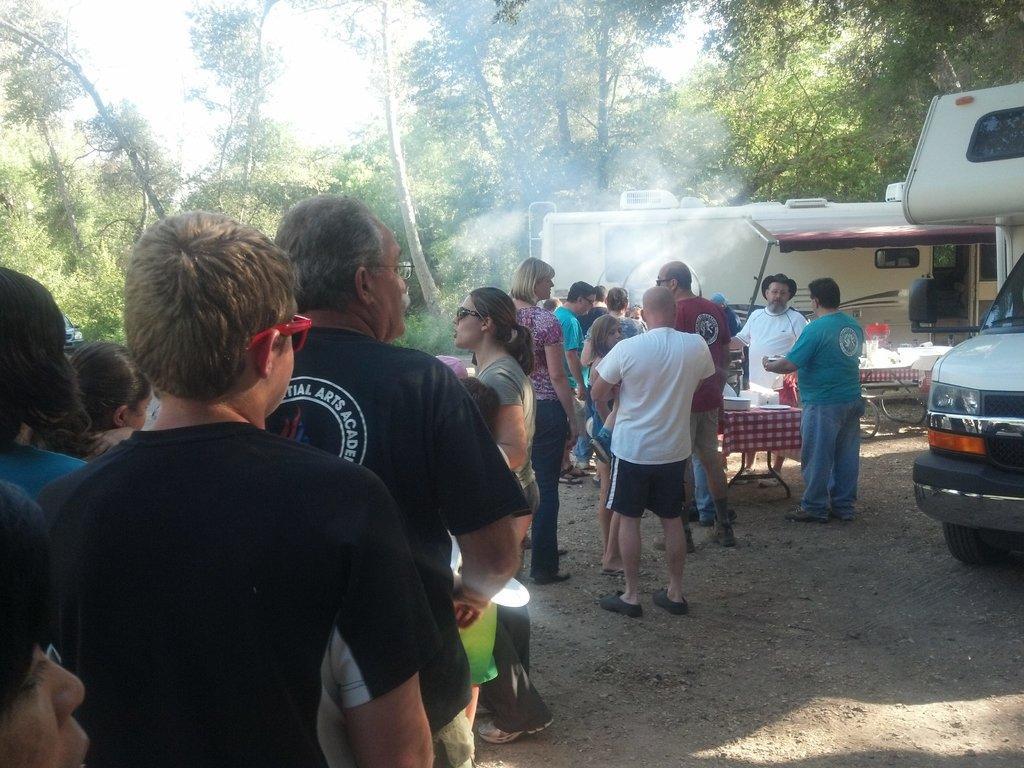How would you summarize this image in a sentence or two? In this image I can see people are standing. Here I can see a table which has some objects on it. I can also see food trucks. In the background I can see trees and the sky. 